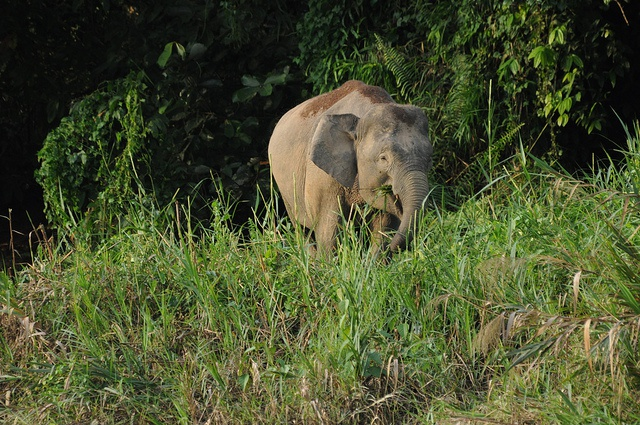Describe the objects in this image and their specific colors. I can see a elephant in black, tan, and gray tones in this image. 